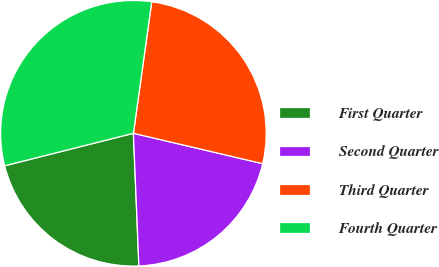Convert chart. <chart><loc_0><loc_0><loc_500><loc_500><pie_chart><fcel>First Quarter<fcel>Second Quarter<fcel>Third Quarter<fcel>Fourth Quarter<nl><fcel>21.72%<fcel>20.67%<fcel>26.47%<fcel>31.14%<nl></chart> 